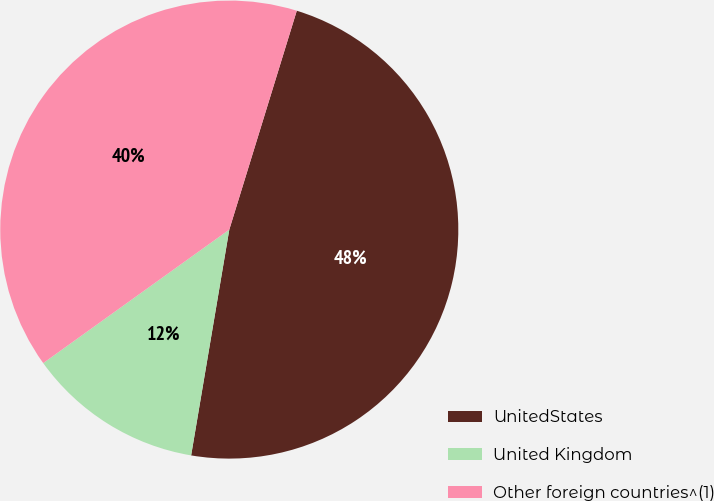<chart> <loc_0><loc_0><loc_500><loc_500><pie_chart><fcel>UnitedStates<fcel>United Kingdom<fcel>Other foreign countries^(1)<nl><fcel>47.91%<fcel>12.43%<fcel>39.67%<nl></chart> 